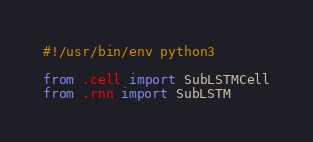Convert code to text. <code><loc_0><loc_0><loc_500><loc_500><_Python_>#!/usr/bin/env python3

from .cell import SubLSTMCell
from .rnn import SubLSTM
</code> 